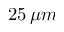Convert formula to latex. <formula><loc_0><loc_0><loc_500><loc_500>2 5 \, \mu m</formula> 